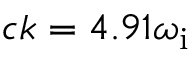<formula> <loc_0><loc_0><loc_500><loc_500>c k = 4 . 9 1 \omega _ { i }</formula> 